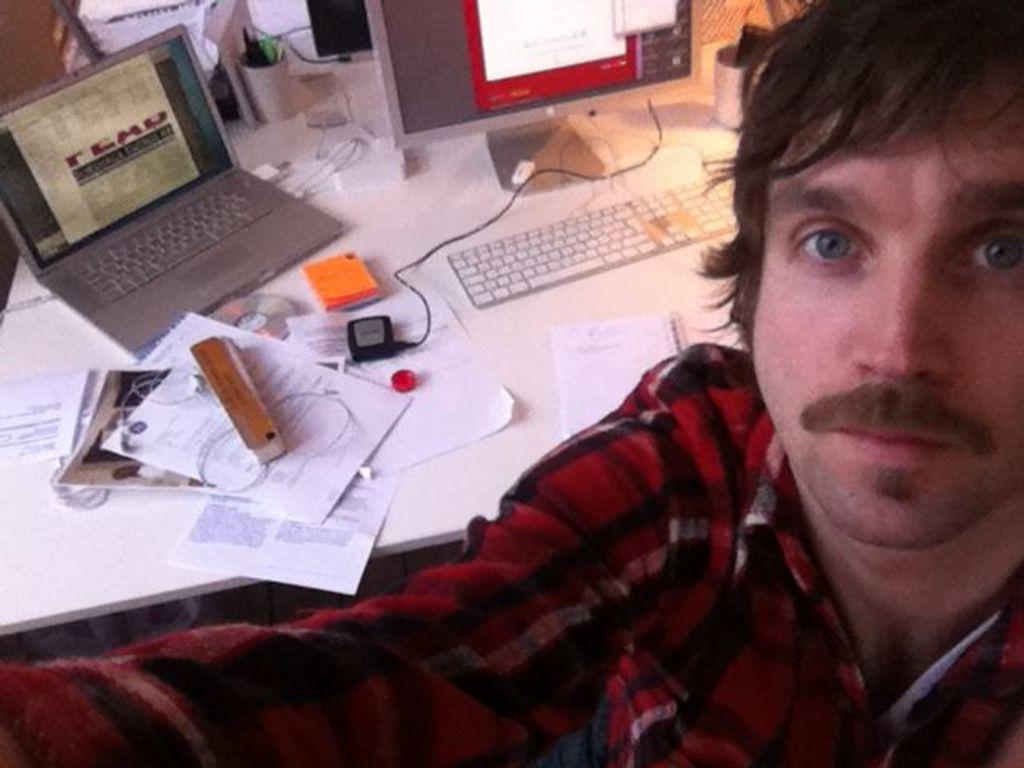Can you describe this image briefly? Here we can see a man. There is a table. On the table we can see a monitor, keyboard, laptop, papers, box, and a cable. 